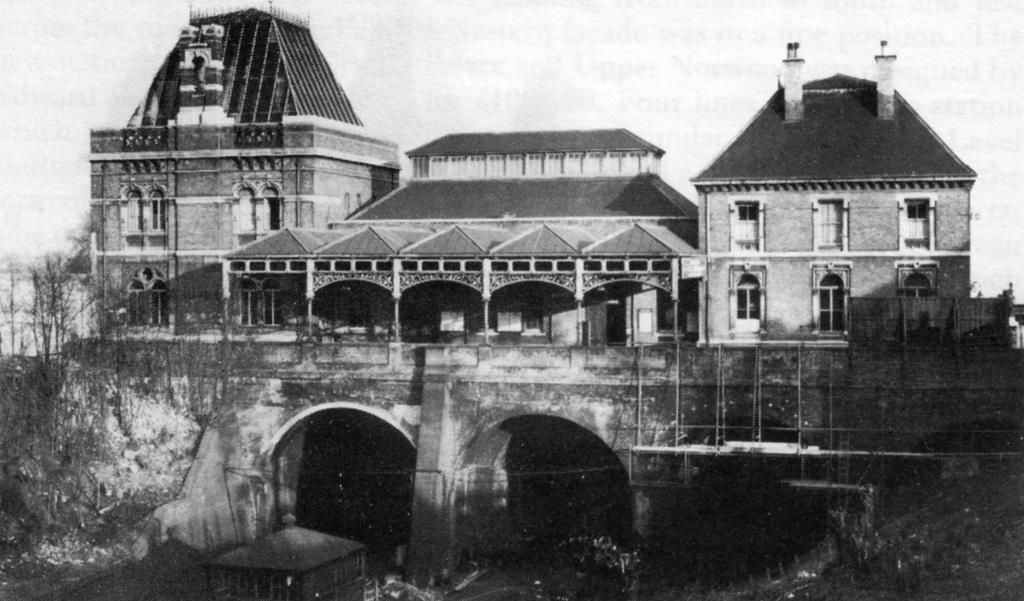Please provide a concise description of this image. In this picture there is a building in the foreground and there are trees. At the top there is sky. 